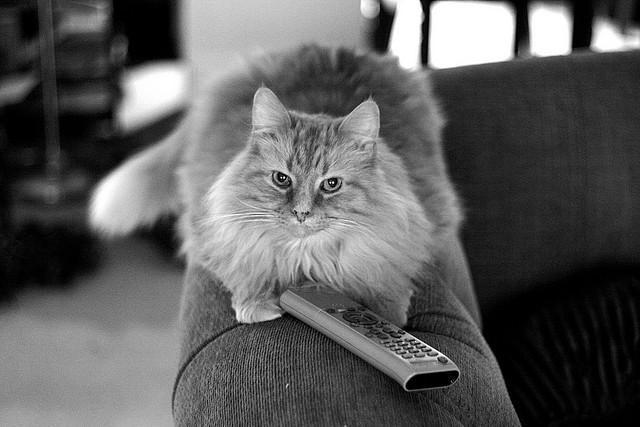How is the cat on the couch illuminated?
Make your selection from the four choices given to correctly answer the question.
Options: Moonlight, sunlight, led light, fluorescent light. Sunlight. 